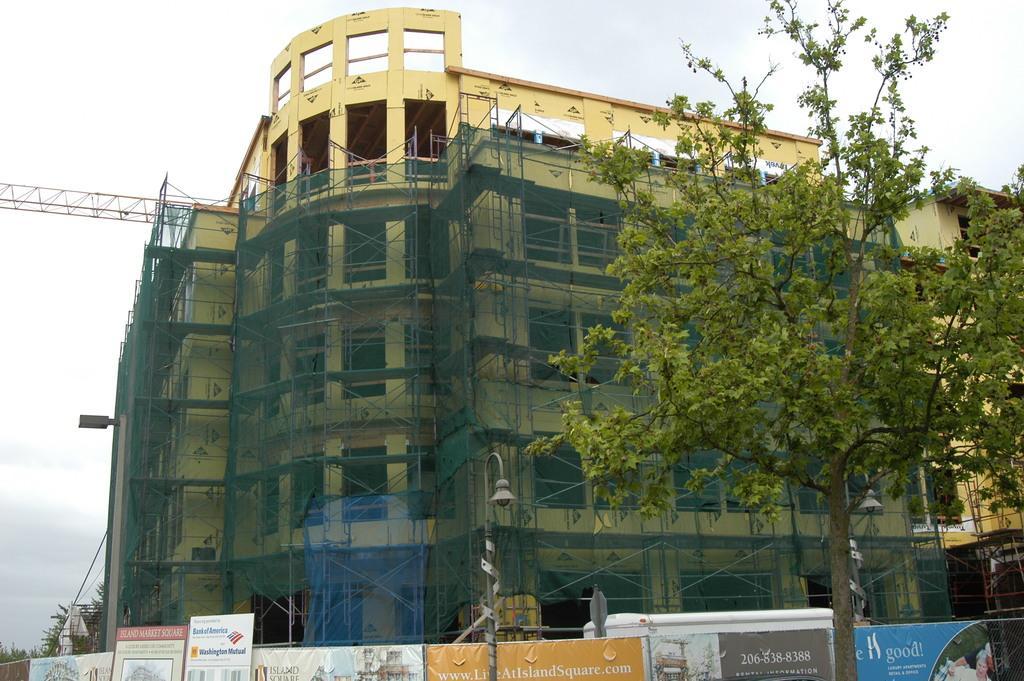Please provide a concise description of this image. In the image there is a building in the back with a tree in front of it and a fence around it and above its sky. 